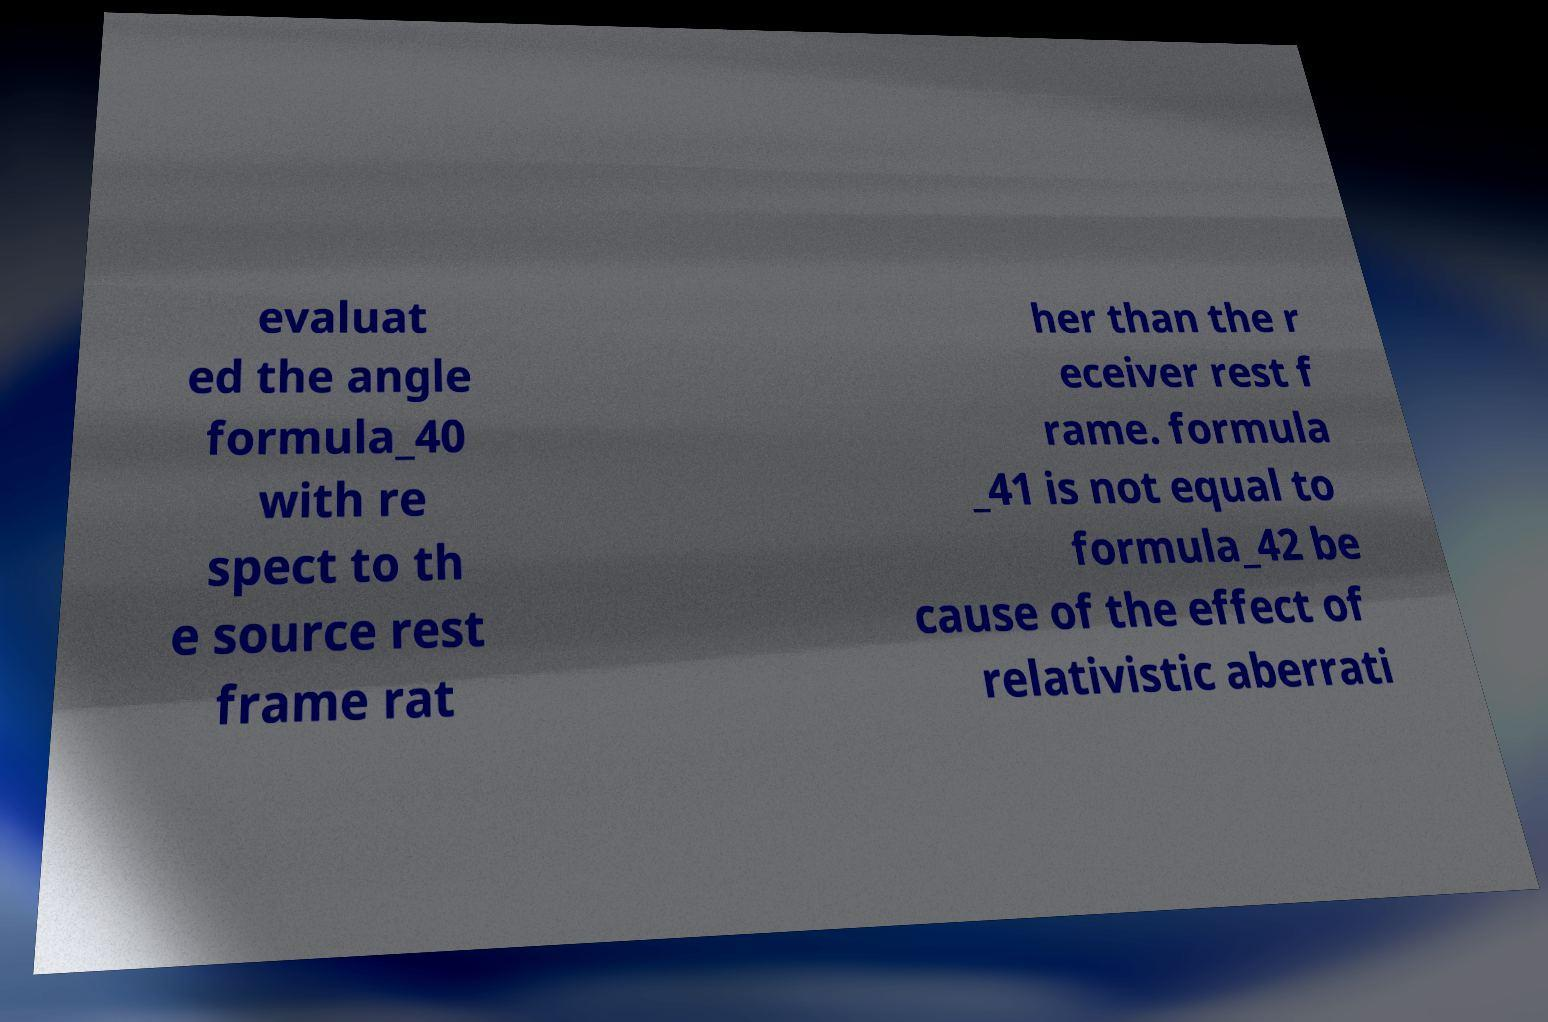I need the written content from this picture converted into text. Can you do that? evaluat ed the angle formula_40 with re spect to th e source rest frame rat her than the r eceiver rest f rame. formula _41 is not equal to formula_42 be cause of the effect of relativistic aberrati 